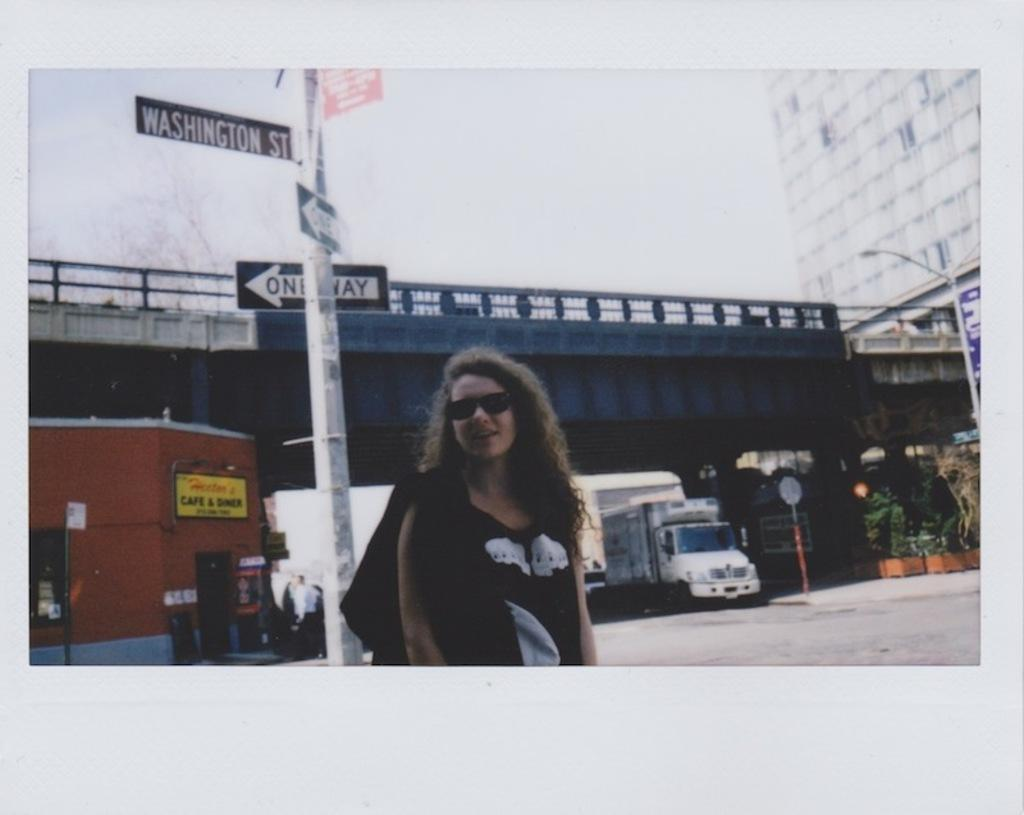What is the main subject in the foreground of the image? There is a girl standing in the foreground of the image. What can be seen in the background of the image? There are plants, poles, vehicles, a building, a bridge, and the sky visible in the background of the image. What type of guitar is the owl holding while sitting on the egg in the image? There is no guitar, owl, or egg present in the image. 